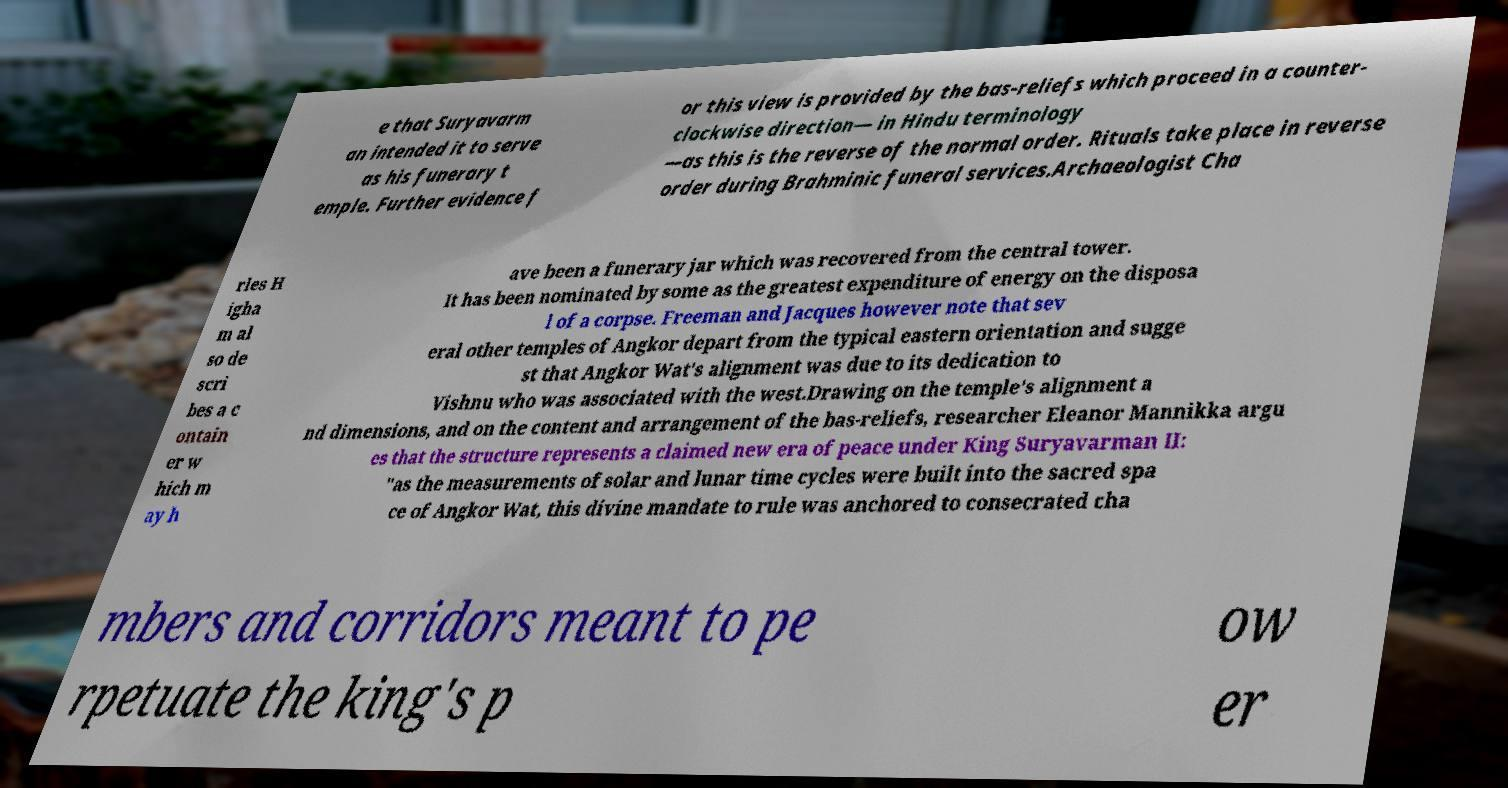Can you read and provide the text displayed in the image?This photo seems to have some interesting text. Can you extract and type it out for me? e that Suryavarm an intended it to serve as his funerary t emple. Further evidence f or this view is provided by the bas-reliefs which proceed in a counter- clockwise direction— in Hindu terminology —as this is the reverse of the normal order. Rituals take place in reverse order during Brahminic funeral services.Archaeologist Cha rles H igha m al so de scri bes a c ontain er w hich m ay h ave been a funerary jar which was recovered from the central tower. It has been nominated by some as the greatest expenditure of energy on the disposa l of a corpse. Freeman and Jacques however note that sev eral other temples of Angkor depart from the typical eastern orientation and sugge st that Angkor Wat's alignment was due to its dedication to Vishnu who was associated with the west.Drawing on the temple's alignment a nd dimensions, and on the content and arrangement of the bas-reliefs, researcher Eleanor Mannikka argu es that the structure represents a claimed new era of peace under King Suryavarman II: "as the measurements of solar and lunar time cycles were built into the sacred spa ce of Angkor Wat, this divine mandate to rule was anchored to consecrated cha mbers and corridors meant to pe rpetuate the king's p ow er 